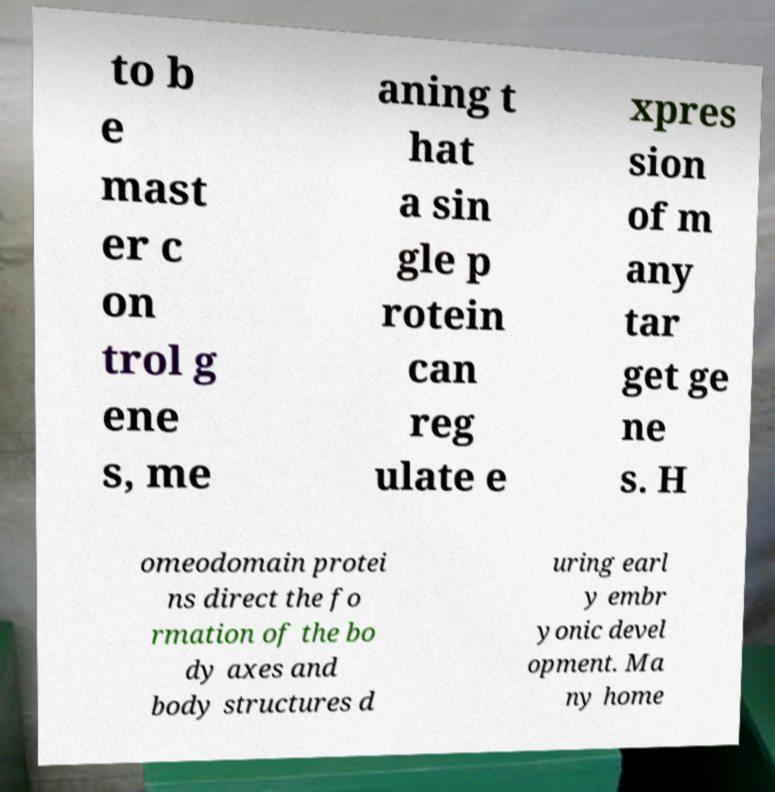What messages or text are displayed in this image? I need them in a readable, typed format. to b e mast er c on trol g ene s, me aning t hat a sin gle p rotein can reg ulate e xpres sion of m any tar get ge ne s. H omeodomain protei ns direct the fo rmation of the bo dy axes and body structures d uring earl y embr yonic devel opment. Ma ny home 